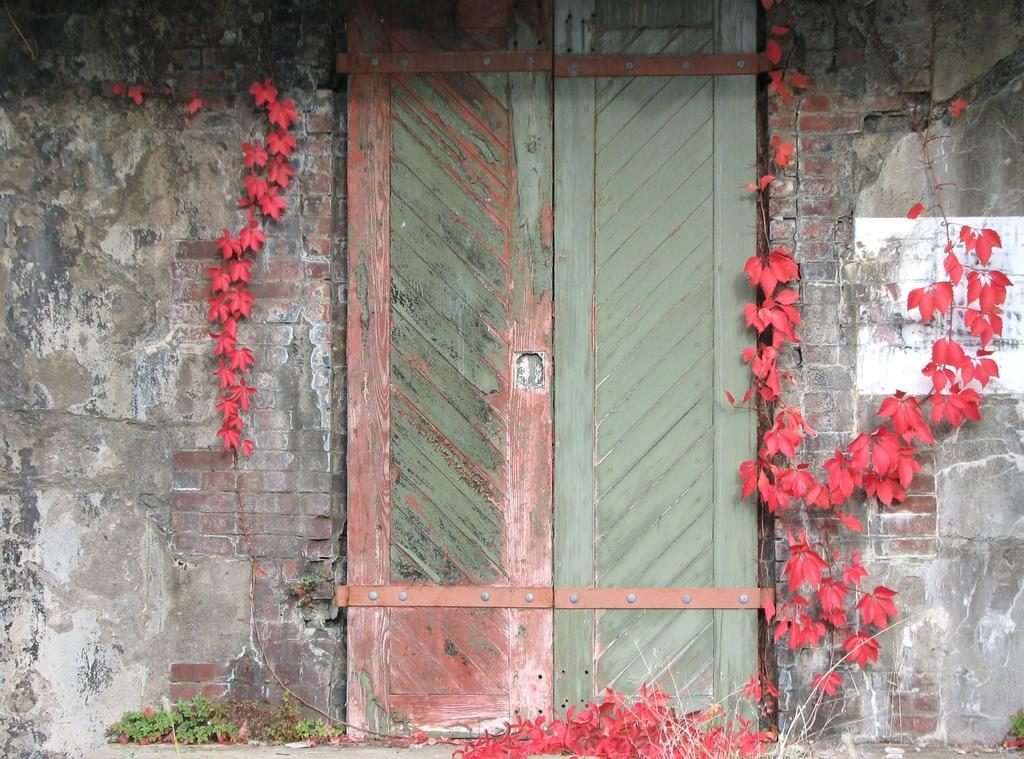What type of structure is visible in the image? There is a house in the image. What is a feature of the house that can be seen in the image? There is a door in the image. What type of vegetation is present in the image? There are plants in the image. What color is the cream on the canvas in the image? There is no canvas or cream present in the image. 